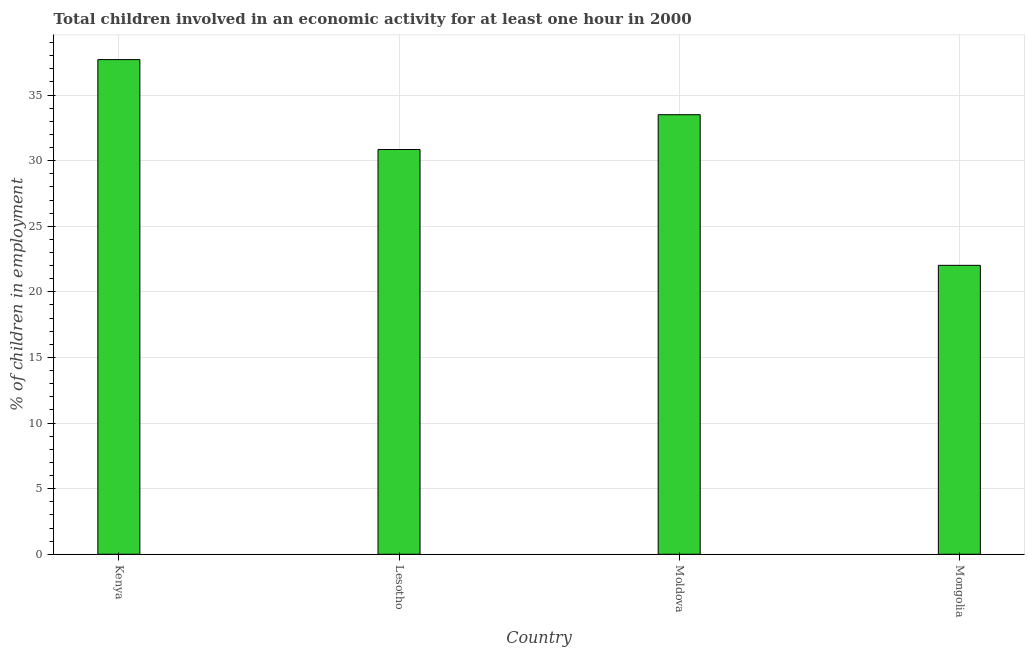Does the graph contain grids?
Give a very brief answer. Yes. What is the title of the graph?
Make the answer very short. Total children involved in an economic activity for at least one hour in 2000. What is the label or title of the Y-axis?
Offer a very short reply. % of children in employment. What is the percentage of children in employment in Kenya?
Give a very brief answer. 37.7. Across all countries, what is the maximum percentage of children in employment?
Offer a terse response. 37.7. Across all countries, what is the minimum percentage of children in employment?
Give a very brief answer. 22.02. In which country was the percentage of children in employment maximum?
Provide a short and direct response. Kenya. In which country was the percentage of children in employment minimum?
Offer a very short reply. Mongolia. What is the sum of the percentage of children in employment?
Make the answer very short. 124.07. What is the difference between the percentage of children in employment in Lesotho and Mongolia?
Provide a succinct answer. 8.83. What is the average percentage of children in employment per country?
Offer a very short reply. 31.02. What is the median percentage of children in employment?
Offer a very short reply. 32.17. In how many countries, is the percentage of children in employment greater than 13 %?
Your answer should be very brief. 4. What is the ratio of the percentage of children in employment in Lesotho to that in Moldova?
Offer a very short reply. 0.92. Is the difference between the percentage of children in employment in Lesotho and Moldova greater than the difference between any two countries?
Offer a very short reply. No. What is the difference between the highest and the lowest percentage of children in employment?
Ensure brevity in your answer.  15.68. In how many countries, is the percentage of children in employment greater than the average percentage of children in employment taken over all countries?
Keep it short and to the point. 2. Are all the bars in the graph horizontal?
Provide a short and direct response. No. How many countries are there in the graph?
Ensure brevity in your answer.  4. What is the difference between two consecutive major ticks on the Y-axis?
Your answer should be compact. 5. What is the % of children in employment in Kenya?
Make the answer very short. 37.7. What is the % of children in employment in Lesotho?
Your answer should be compact. 30.85. What is the % of children in employment of Moldova?
Offer a very short reply. 33.5. What is the % of children in employment of Mongolia?
Your answer should be very brief. 22.02. What is the difference between the % of children in employment in Kenya and Lesotho?
Your response must be concise. 6.85. What is the difference between the % of children in employment in Kenya and Mongolia?
Provide a succinct answer. 15.68. What is the difference between the % of children in employment in Lesotho and Moldova?
Your answer should be very brief. -2.65. What is the difference between the % of children in employment in Lesotho and Mongolia?
Ensure brevity in your answer.  8.83. What is the difference between the % of children in employment in Moldova and Mongolia?
Give a very brief answer. 11.48. What is the ratio of the % of children in employment in Kenya to that in Lesotho?
Give a very brief answer. 1.22. What is the ratio of the % of children in employment in Kenya to that in Mongolia?
Offer a terse response. 1.71. What is the ratio of the % of children in employment in Lesotho to that in Moldova?
Offer a very short reply. 0.92. What is the ratio of the % of children in employment in Lesotho to that in Mongolia?
Your answer should be compact. 1.4. What is the ratio of the % of children in employment in Moldova to that in Mongolia?
Make the answer very short. 1.52. 